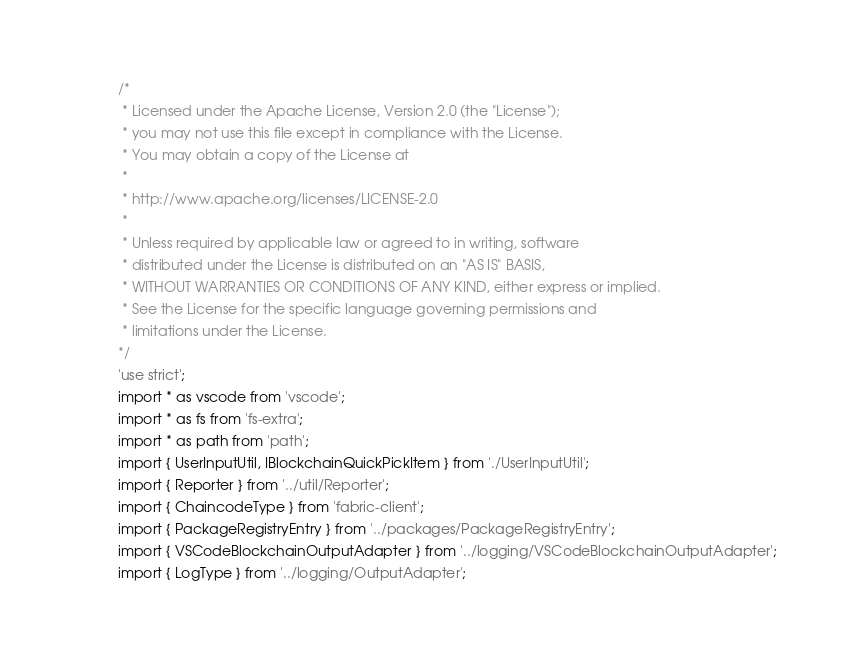Convert code to text. <code><loc_0><loc_0><loc_500><loc_500><_TypeScript_>/*
 * Licensed under the Apache License, Version 2.0 (the "License");
 * you may not use this file except in compliance with the License.
 * You may obtain a copy of the License at
 *
 * http://www.apache.org/licenses/LICENSE-2.0
 *
 * Unless required by applicable law or agreed to in writing, software
 * distributed under the License is distributed on an "AS IS" BASIS,
 * WITHOUT WARRANTIES OR CONDITIONS OF ANY KIND, either express or implied.
 * See the License for the specific language governing permissions and
 * limitations under the License.
*/
'use strict';
import * as vscode from 'vscode';
import * as fs from 'fs-extra';
import * as path from 'path';
import { UserInputUtil, IBlockchainQuickPickItem } from './UserInputUtil';
import { Reporter } from '../util/Reporter';
import { ChaincodeType } from 'fabric-client';
import { PackageRegistryEntry } from '../packages/PackageRegistryEntry';
import { VSCodeBlockchainOutputAdapter } from '../logging/VSCodeBlockchainOutputAdapter';
import { LogType } from '../logging/OutputAdapter';</code> 